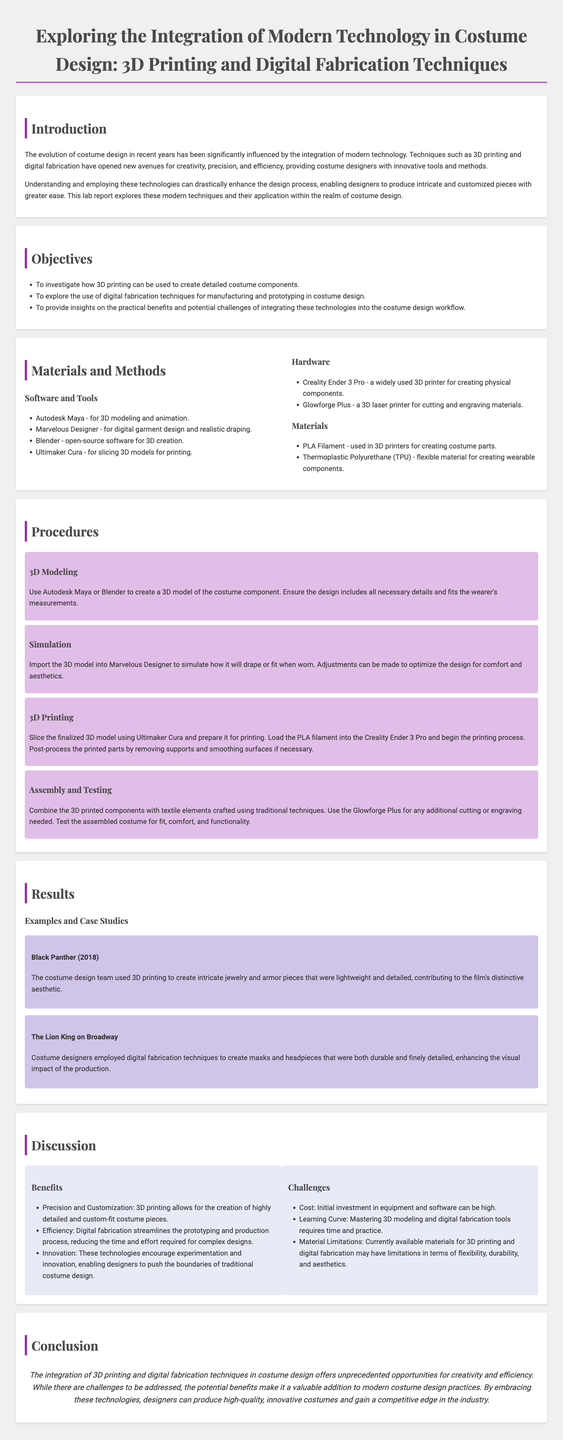What are the main technologies explored in this report? The report discusses the integration of 3D printing and digital fabrication techniques in costume design.
Answer: 3D printing and digital fabrication techniques What materials are used in 3D printing according to the report? The report lists PLA filament and Thermoplastic Polyurethane (TPU) as the materials used in 3D printing for costume parts.
Answer: PLA Filament and Thermoplastic Polyurethane (TPU) How many objectives are outlined in the report? The report mentions a total of three objectives related to the use of modern technologies in costume design.
Answer: Three Which software is used for 3D modeling in the costume design process? The software used for 3D modeling includes Autodesk Maya and Blender.
Answer: Autodesk Maya and Blender What was a specific use of 3D printing in the case study of "Black Panther"? In "Black Panther", 3D printing was used to create intricate jewelry and armor pieces.
Answer: Intricate jewelry and armor pieces What is one benefit of using digital fabrication in costume design mentioned in the report? The report mentions that digital fabrication streamlines the prototyping and production process, reducing time and effort.
Answer: Streamlined prototyping and production process What is the primary challenge regarding the integration of these technologies? The report highlights that the initial investment in equipment and software is a primary challenge.
Answer: Cost How are 3D printed components combined with traditional techniques? The report states that 3D printed components are combined with textile elements crafted using traditional techniques.
Answer: Combined with textile elements What is the concluding sentiment about modern technology's incorporation into costume design? The conclusion suggests that integrating modern technology provides unprecedented opportunities for creativity and efficiency.
Answer: Unprecedented opportunities for creativity and efficiency 